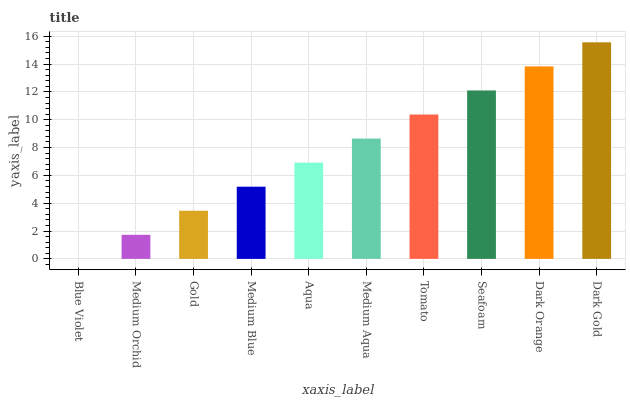Is Blue Violet the minimum?
Answer yes or no. Yes. Is Dark Gold the maximum?
Answer yes or no. Yes. Is Medium Orchid the minimum?
Answer yes or no. No. Is Medium Orchid the maximum?
Answer yes or no. No. Is Medium Orchid greater than Blue Violet?
Answer yes or no. Yes. Is Blue Violet less than Medium Orchid?
Answer yes or no. Yes. Is Blue Violet greater than Medium Orchid?
Answer yes or no. No. Is Medium Orchid less than Blue Violet?
Answer yes or no. No. Is Medium Aqua the high median?
Answer yes or no. Yes. Is Aqua the low median?
Answer yes or no. Yes. Is Seafoam the high median?
Answer yes or no. No. Is Medium Aqua the low median?
Answer yes or no. No. 